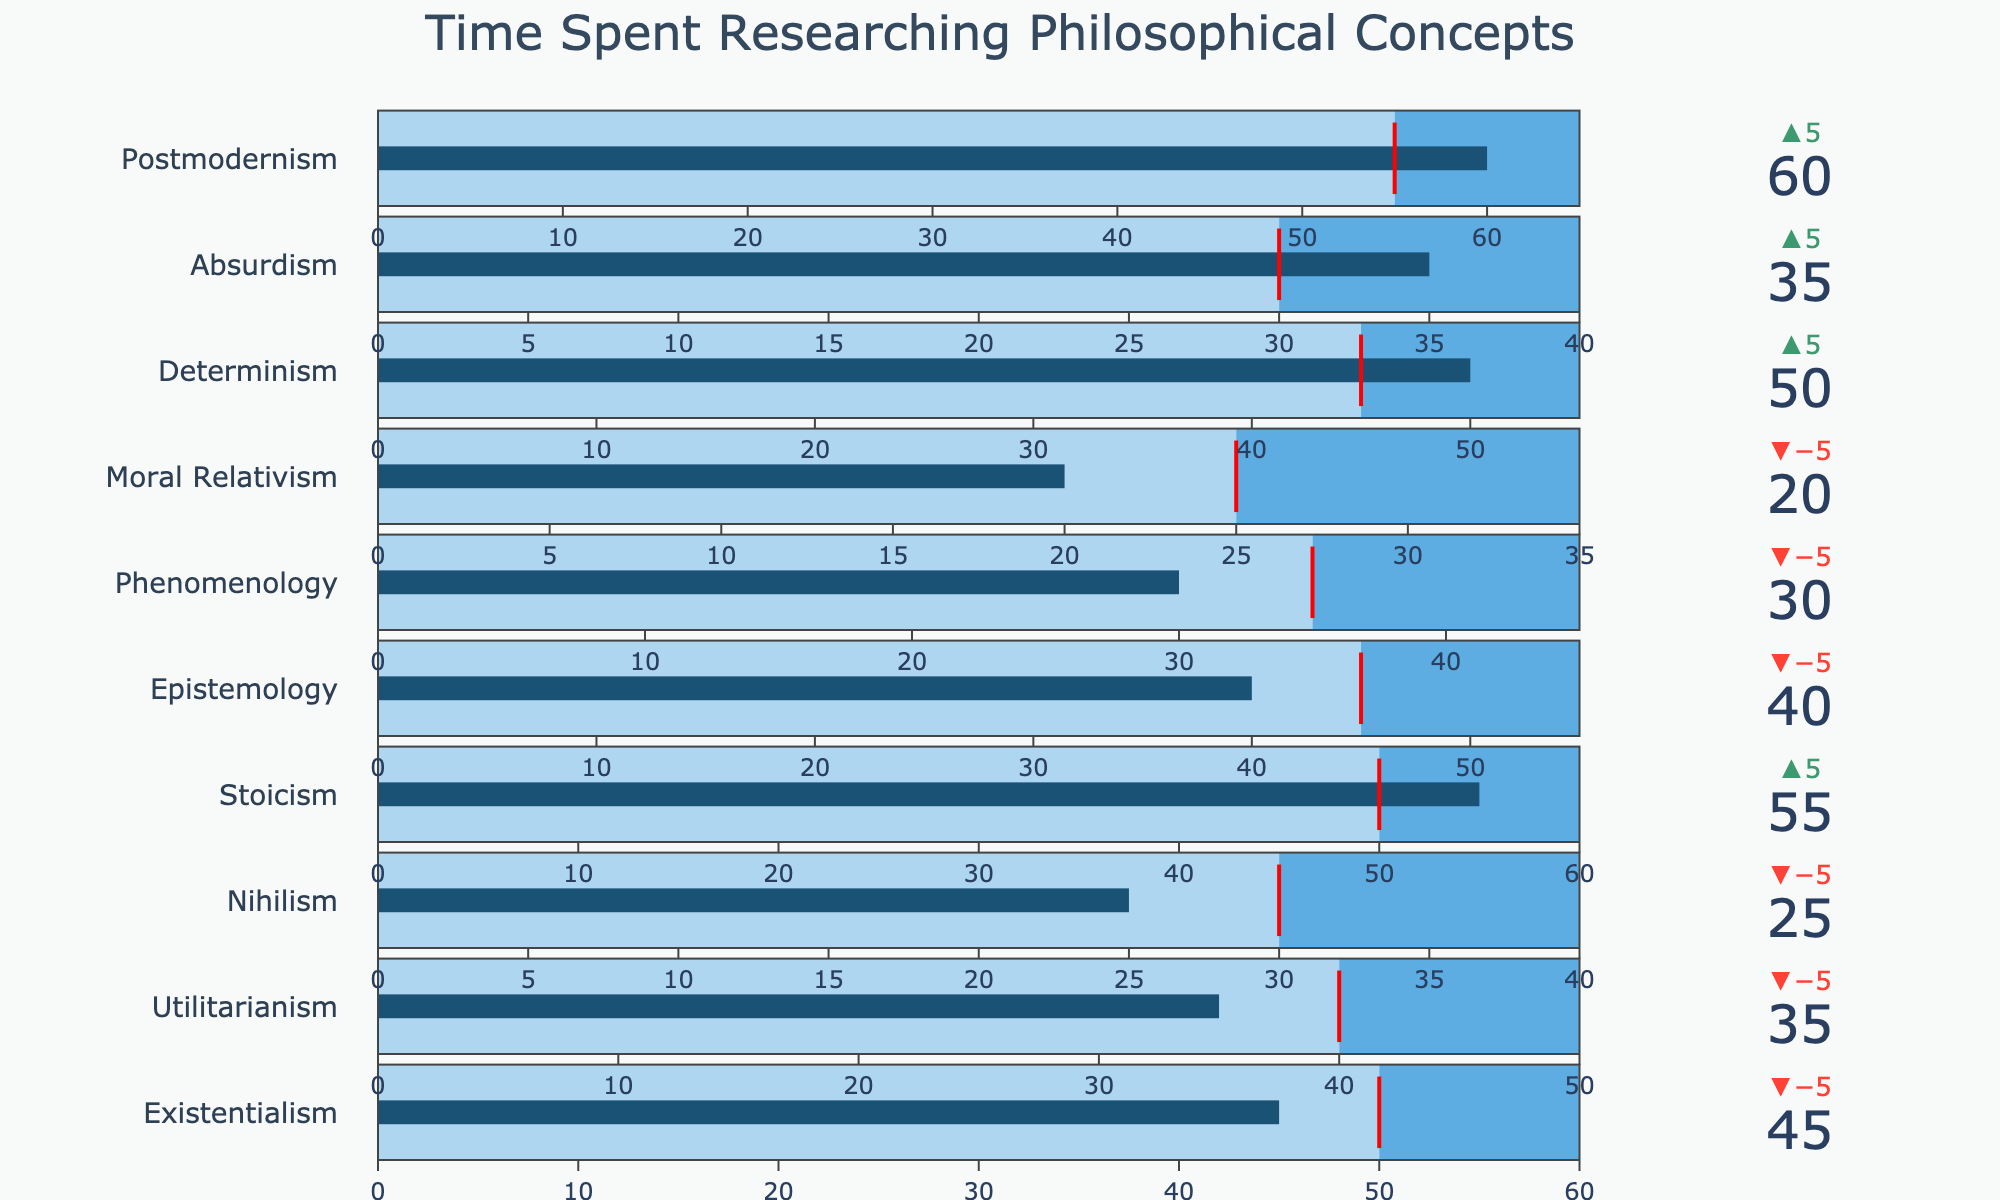Which philosophical concept had the highest actual hours spent? Observe the bullet chart and identify the bar with the highest value in the "Actual Hours" section. The concept with the highest actual hours is "Postmodernism" with 60 hours.
Answer: Postmodernism Which philosophical concept narrowly missed its goal hours? Look for the concept where the "Actual Hours" is slightly less than the "Goal Hours" as indicated by the threshold line. "Existentialism" had a goal of 50 hours and its actual hours are 45, narrowly missing its goal.
Answer: Existentialism How many concepts met or exceeded their goal hours? Count all the concepts in the bullet chart where the "Actual Hours" bar is equal to or greater than the "Goal Hours" threshold. The concepts are Stoicism, Determinism, Absurdism, and Postmodernism.
Answer: 4 Which concept has the largest difference between its actual hours and its goal hours? Calculate the difference between "Actual Hours" and "Goal Hours" for each concept and identify the largest difference. For Postmodernism, the difference is \(60 - 55 = 5\).
Answer: Postmodernism What's the average of actual hours spent across all concepts? Sum the actual hours for all concepts and divide by the number of concepts. The sum of actual hours is \(45 + 35 + 25 + 55 + 40 + 30 + 20 + 50 + 35 + 60 = 395\). There are 10 concepts, so the average is \(395/10 = 39.5\).
Answer: 39.5 Which concepts exceeded their maximum hours? Check if any "Actual Hours" bar surpasses the "Maximum Hours" range in the bullet chart. None of the concepts exceed their maximum hours.
Answer: None Compare the actual hours spent on Epistemology and Phenomenology. Which spent more? Check the actual hours on both Epistemology and Phenomenology. Epistemology is 40 hours, and Phenomenology is 30 hours. Epistemology spent more.
Answer: Epistemology Did any concept have actual hours exactly equal to its maximum hours? Observe if any actual hours bar aligns perfectly with the maximum hours threshold. None of the concepts have actual hours equal to their maximum hours.
Answer: None Which concept had the lowest actual hours spent? Identify the bar with the lowest value in the "Actual Hours" section. The concept with the lowest actual hours is "Moral Relativism" with 20 hours.
Answer: Moral Relativism By how many hours did Stoicism exceed its goal hours? Subtract the goal hours of Stoicism from its actual hours. For Stoicism, actual hours are 55, and the goal hours are 50, so the difference is \(55 - 50 = 5\).
Answer: 5 